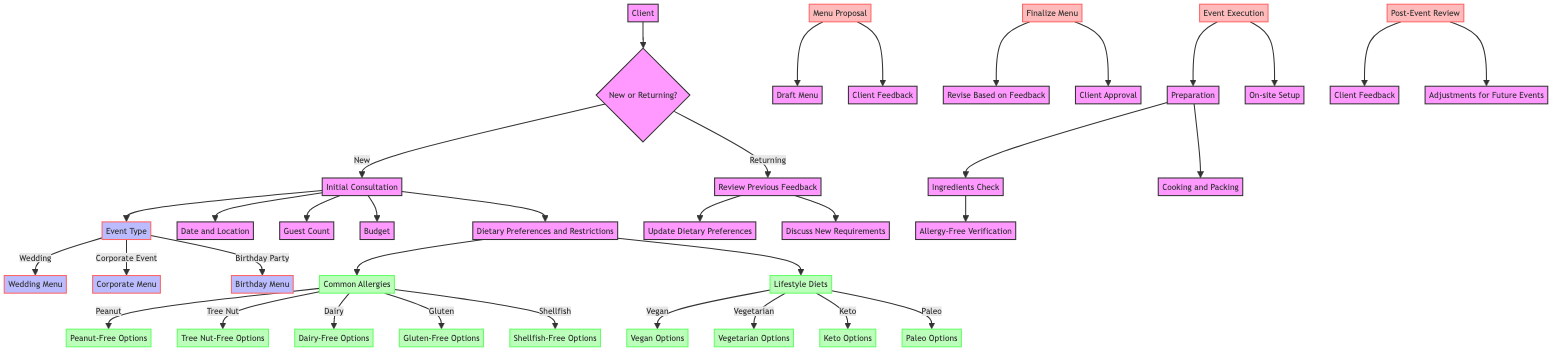What is the first step for a new client? The diagram shows that the first step for a new client is the "Initial Consultation." This node is connected directly under "New Client," indicating it is the first action taken.
Answer: Initial Consultation How many event types are listed in the diagram? In the "Event Type" node, there are three options listed: Wedding, Corporate Event, and Birthday Party. By counting each option, we find a total of three event types.
Answer: 3 What must be verified during the ingredient preparation? The diagram specifies that during the "Ingredients Check," there is a sub-node for "Allergy-Free Verification." This indicates the need to confirm that ingredients do not contain allergens.
Answer: Allergy-Free Verification What dietary restriction options are available for dairy allergies? The diagram indicates that there is a specific option for dairy allergies, labeled as "Dairy-Free Options." This means that for clients with dairy allergies, dairy-free menu items will be proposed.
Answer: Dairy-Free Options When does the "Client Approval" happen in the process? According to the diagram, "Client Approval" occurs after the "Revise Based on Feedback" step within the "Finalize Menu" section. The flow indicates that client approval is a necessary step before finalizing the menu.
Answer: Client Approval What happens after receiving feedback from the client? The feedback from the client leads to the "Revise Based on Feedback" process, which indicates that adjustments will be made to the menu based on the client’s input. This is essential for aligning the menu with the client's preferences.
Answer: Revise Based on Feedback Which dietary restrictions fall under "Common Allergies"? The "Common Allergies" node lists five specific allergies: Peanut, Tree Nut, Dairy, Gluten, and Shellfish. These allergies represent common dietary restrictions that must be managed when planning the menu.
Answer: Peanut, Tree Nut, Dairy, Gluten, Shellfish What is the next step after "Discuss New Requirements" for returning clients? After "Discuss New Requirements," the diagram indicates moving to either "Update Dietary Preferences" or directly into the next event type, depending on the client's situation. The flow connects these two nodes directly, illustrating possible next steps.
Answer: Update Dietary Preferences What is the last step noted in the diagram? The diagram concludes with the "Adjustments for Future Events" under "Post-Event Review." This node indicates that after the event, feedback and insights are used to improve future catering endeavors.
Answer: Adjustments for Future Events 